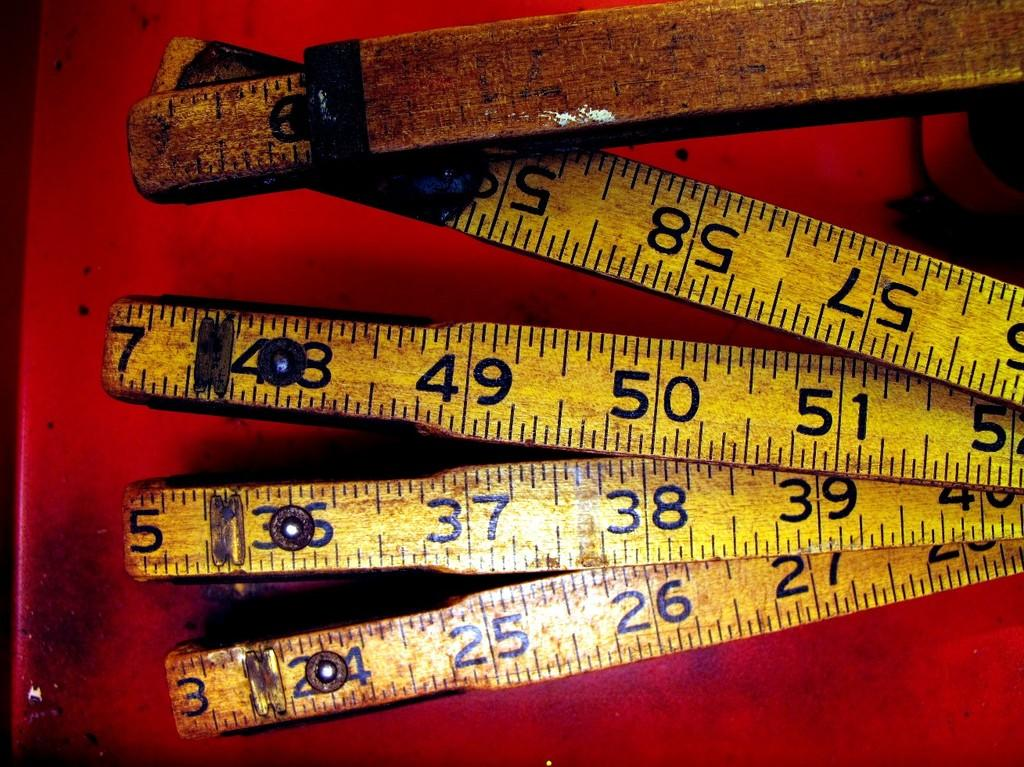<image>
Relay a brief, clear account of the picture shown. A bunch of old tape measures with numbers like 27, 39, 51, and 57 are laid out. 